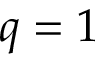<formula> <loc_0><loc_0><loc_500><loc_500>q = 1</formula> 